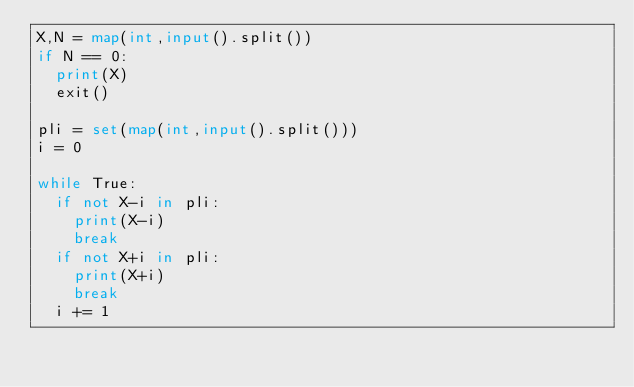<code> <loc_0><loc_0><loc_500><loc_500><_Python_>X,N = map(int,input().split())
if N == 0:
  print(X)
  exit()

pli = set(map(int,input().split()))
i = 0

while True:
  if not X-i in pli:
    print(X-i)
    break
  if not X+i in pli:
    print(X+i)
    break
  i += 1</code> 